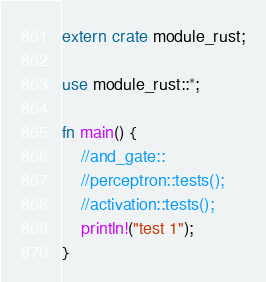Convert code to text. <code><loc_0><loc_0><loc_500><loc_500><_Rust_>extern crate module_rust;

use module_rust::*;

fn main() {
    //and_gate::
    //perceptron::tests();
    //activation::tests();
    println!("test 1");
}
</code> 